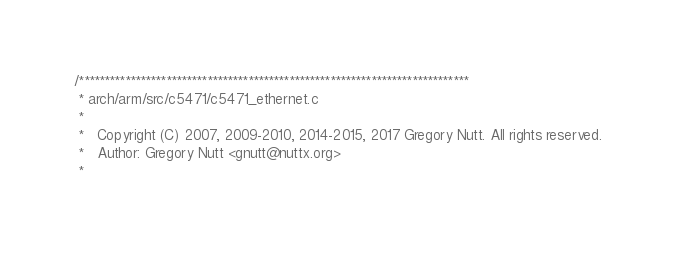Convert code to text. <code><loc_0><loc_0><loc_500><loc_500><_C_>/****************************************************************************
 * arch/arm/src/c5471/c5471_ethernet.c
 *
 *   Copyright (C) 2007, 2009-2010, 2014-2015, 2017 Gregory Nutt. All rights reserved.
 *   Author: Gregory Nutt <gnutt@nuttx.org>
 *</code> 